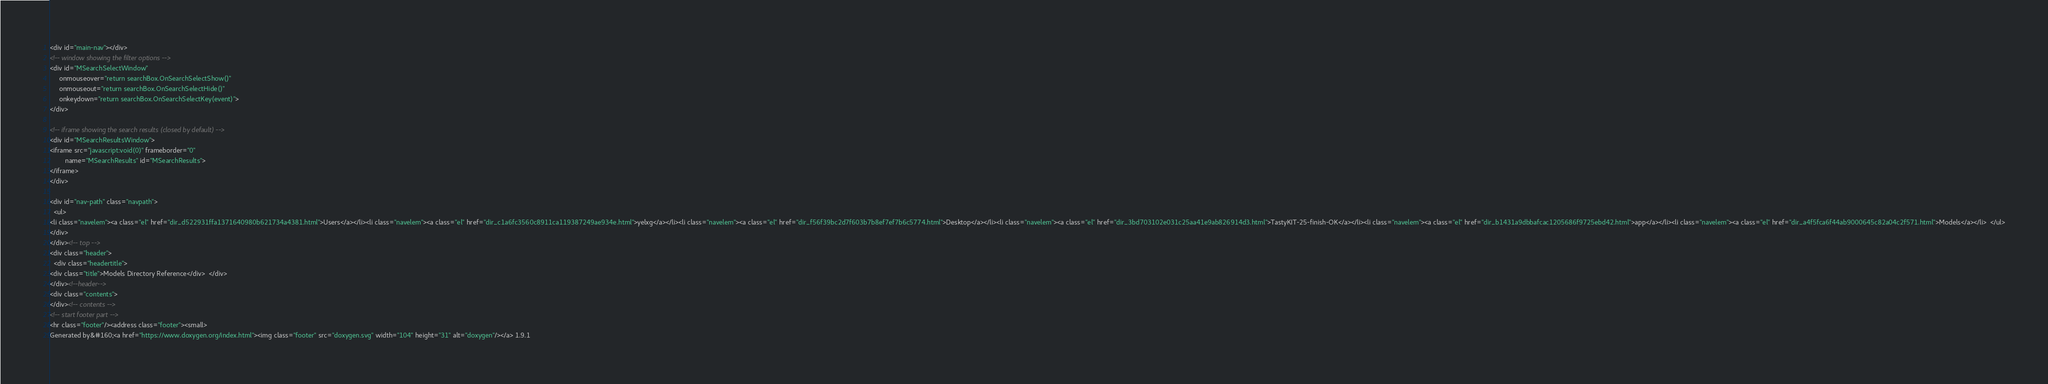Convert code to text. <code><loc_0><loc_0><loc_500><loc_500><_HTML_><div id="main-nav"></div>
<!-- window showing the filter options -->
<div id="MSearchSelectWindow"
     onmouseover="return searchBox.OnSearchSelectShow()"
     onmouseout="return searchBox.OnSearchSelectHide()"
     onkeydown="return searchBox.OnSearchSelectKey(event)">
</div>

<!-- iframe showing the search results (closed by default) -->
<div id="MSearchResultsWindow">
<iframe src="javascript:void(0)" frameborder="0" 
        name="MSearchResults" id="MSearchResults">
</iframe>
</div>

<div id="nav-path" class="navpath">
  <ul>
<li class="navelem"><a class="el" href="dir_d522931ffa1371640980b621734a4381.html">Users</a></li><li class="navelem"><a class="el" href="dir_c1a6fc3560c8911ca119387249ae934e.html">yelxg</a></li><li class="navelem"><a class="el" href="dir_f56f39bc2d7f603b7b8ef7ef7b6c5774.html">Desktop</a></li><li class="navelem"><a class="el" href="dir_3bd703102e031c25aa41e9ab826914d3.html">TastyKIT-25-finish-OK</a></li><li class="navelem"><a class="el" href="dir_b1431a9dbbafcac1205686f9725ebd42.html">app</a></li><li class="navelem"><a class="el" href="dir_a4f5fca6f44ab9000645c82a04c2f571.html">Models</a></li>  </ul>
</div>
</div><!-- top -->
<div class="header">
  <div class="headertitle">
<div class="title">Models Directory Reference</div>  </div>
</div><!--header-->
<div class="contents">
</div><!-- contents -->
<!-- start footer part -->
<hr class="footer"/><address class="footer"><small>
Generated by&#160;<a href="https://www.doxygen.org/index.html"><img class="footer" src="doxygen.svg" width="104" height="31" alt="doxygen"/></a> 1.9.1</code> 